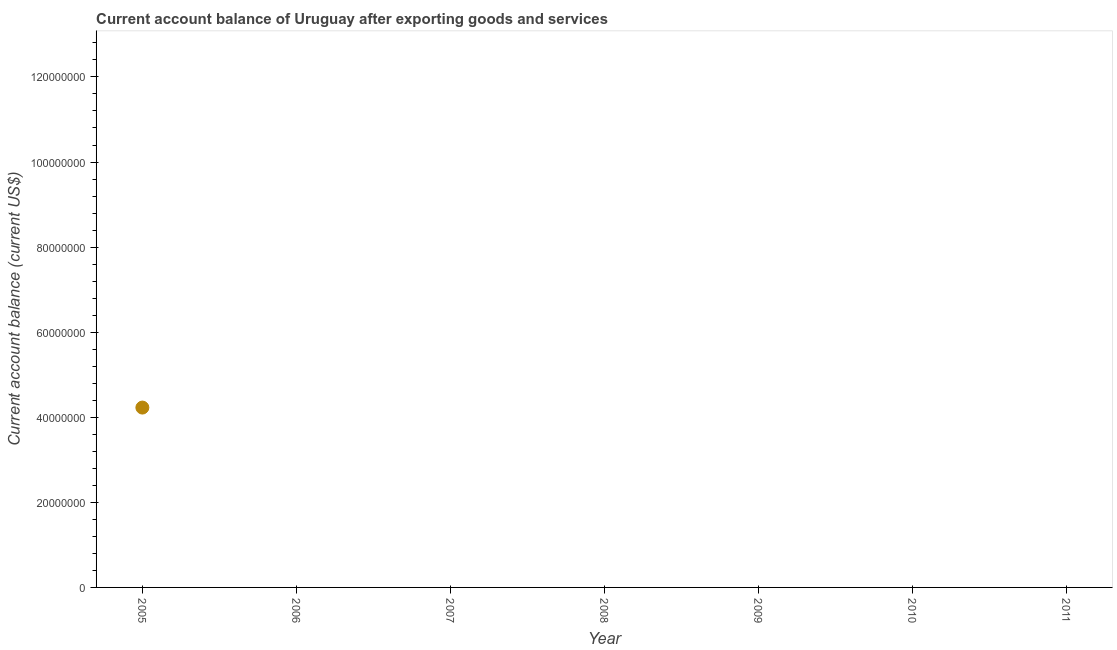Across all years, what is the maximum current account balance?
Offer a terse response. 4.23e+07. Across all years, what is the minimum current account balance?
Ensure brevity in your answer.  0. What is the sum of the current account balance?
Offer a very short reply. 4.23e+07. What is the average current account balance per year?
Keep it short and to the point. 6.04e+06. What is the median current account balance?
Make the answer very short. 0. In how many years, is the current account balance greater than 68000000 US$?
Offer a terse response. 0. What is the difference between the highest and the lowest current account balance?
Make the answer very short. 4.23e+07. In how many years, is the current account balance greater than the average current account balance taken over all years?
Ensure brevity in your answer.  1. Does the current account balance monotonically increase over the years?
Offer a very short reply. No. How many years are there in the graph?
Keep it short and to the point. 7. What is the difference between two consecutive major ticks on the Y-axis?
Offer a terse response. 2.00e+07. Are the values on the major ticks of Y-axis written in scientific E-notation?
Provide a short and direct response. No. Does the graph contain grids?
Keep it short and to the point. No. What is the title of the graph?
Keep it short and to the point. Current account balance of Uruguay after exporting goods and services. What is the label or title of the Y-axis?
Offer a very short reply. Current account balance (current US$). What is the Current account balance (current US$) in 2005?
Offer a very short reply. 4.23e+07. What is the Current account balance (current US$) in 2006?
Your answer should be very brief. 0. What is the Current account balance (current US$) in 2007?
Provide a short and direct response. 0. What is the Current account balance (current US$) in 2009?
Give a very brief answer. 0. What is the Current account balance (current US$) in 2010?
Offer a terse response. 0. 